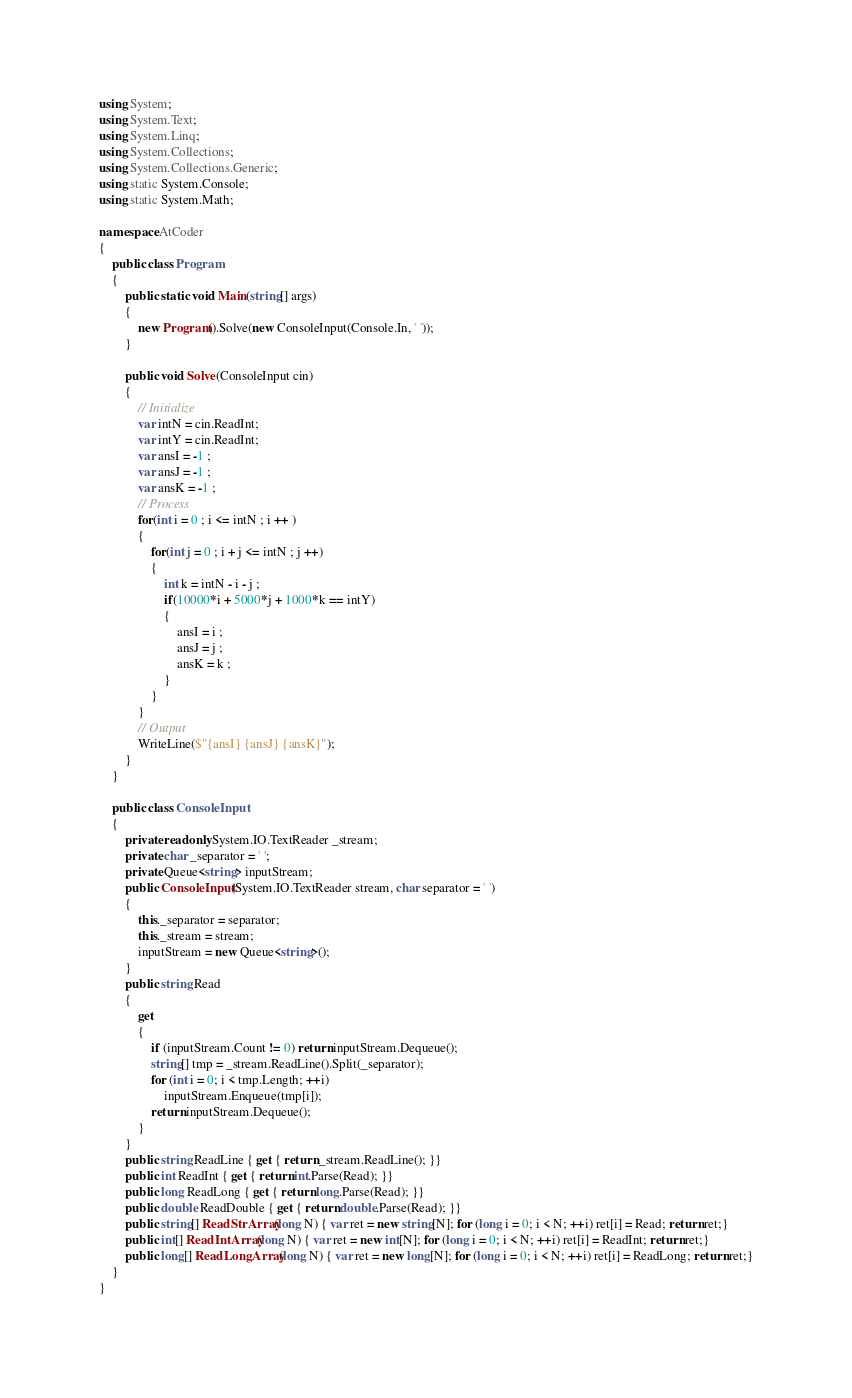<code> <loc_0><loc_0><loc_500><loc_500><_C#_>using System;
using System.Text;
using System.Linq;
using System.Collections;
using System.Collections.Generic;
using static System.Console;
using static System.Math;

namespace AtCoder
{
    public class Program
    {
        public static void Main(string[] args)
        {
            new Program().Solve(new ConsoleInput(Console.In, ' '));
        }

        public void Solve(ConsoleInput cin)
        {
            // Initialize
          	var intN = cin.ReadInt;
          	var intY = cin.ReadInt;
          	var ansI = -1 ;
          	var ansJ = -1 ;
            var ansK = -1 ;
            // Process
			for(int i = 0 ; i <= intN ; i ++ )
            {
            	for(int j = 0 ; i + j <= intN ; j ++)
                {
                	int k = intN - i - j ;
                  	if(10000*i + 5000*j + 1000*k == intY)
                    {
                    	ansI = i ;
                      	ansJ = j ;
                      	ansK = k ;
                    }
                }
            }
           	// Output
        	WriteLine($"{ansI} {ansJ} {ansK}");
        }
    }

    public class ConsoleInput
    {
        private readonly System.IO.TextReader _stream;
        private char _separator = ' ';
        private Queue<string> inputStream;
        public ConsoleInput(System.IO.TextReader stream, char separator = ' ')
        {
            this._separator = separator;
            this._stream = stream;
            inputStream = new Queue<string>();
        }
        public string Read
        {
            get
            {
                if (inputStream.Count != 0) return inputStream.Dequeue();
                string[] tmp = _stream.ReadLine().Split(_separator);
                for (int i = 0; i < tmp.Length; ++i)
                    inputStream.Enqueue(tmp[i]);
                return inputStream.Dequeue();
            }
        }
        public string ReadLine { get { return _stream.ReadLine(); }}
        public int ReadInt { get { return int.Parse(Read); }}
        public long ReadLong { get { return long.Parse(Read); }}
        public double ReadDouble { get { return double.Parse(Read); }}
        public string[] ReadStrArray(long N) { var ret = new string[N]; for (long i = 0; i < N; ++i) ret[i] = Read; return ret;}
        public int[] ReadIntArray(long N) { var ret = new int[N]; for (long i = 0; i < N; ++i) ret[i] = ReadInt; return ret;}
        public long[] ReadLongArray(long N) { var ret = new long[N]; for (long i = 0; i < N; ++i) ret[i] = ReadLong; return ret;}
    }
}</code> 